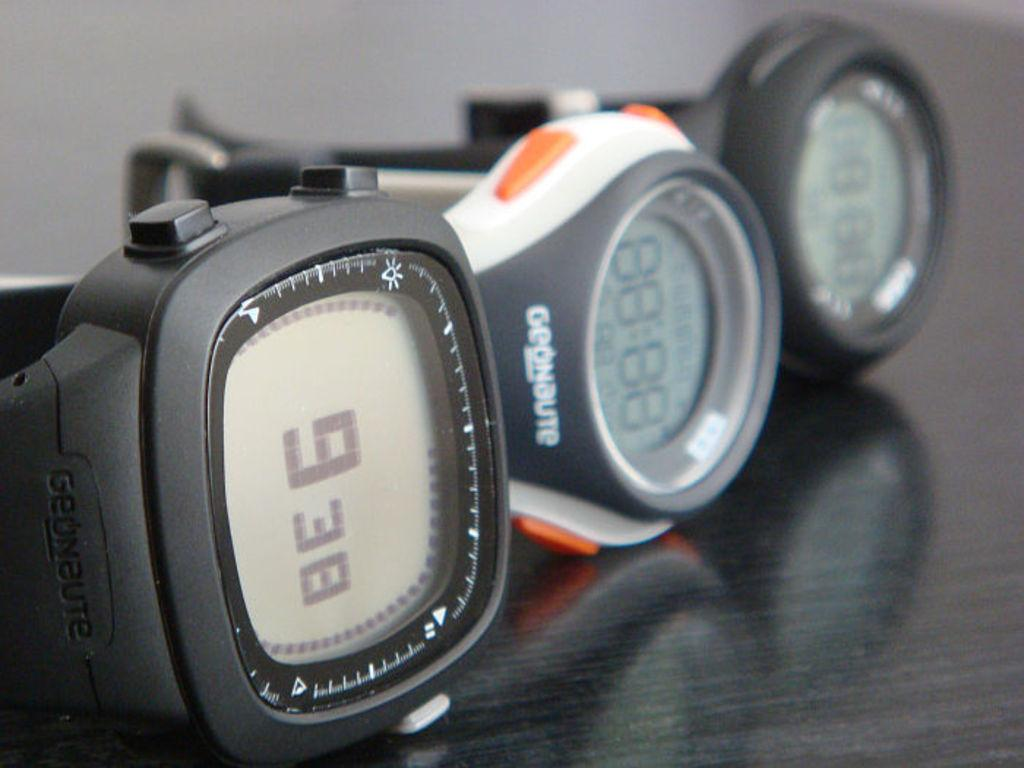How many digital watches are visible in the image? There are three digital watches in the image. Where are the digital watches located? The digital watches are on a table. What type of rock is being used as a paperweight for the digital watches in the image? There is no rock present in the image; the digital watches are simply on a table. 